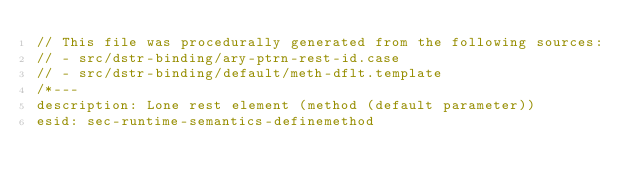<code> <loc_0><loc_0><loc_500><loc_500><_JavaScript_>// This file was procedurally generated from the following sources:
// - src/dstr-binding/ary-ptrn-rest-id.case
// - src/dstr-binding/default/meth-dflt.template
/*---
description: Lone rest element (method (default parameter))
esid: sec-runtime-semantics-definemethod</code> 